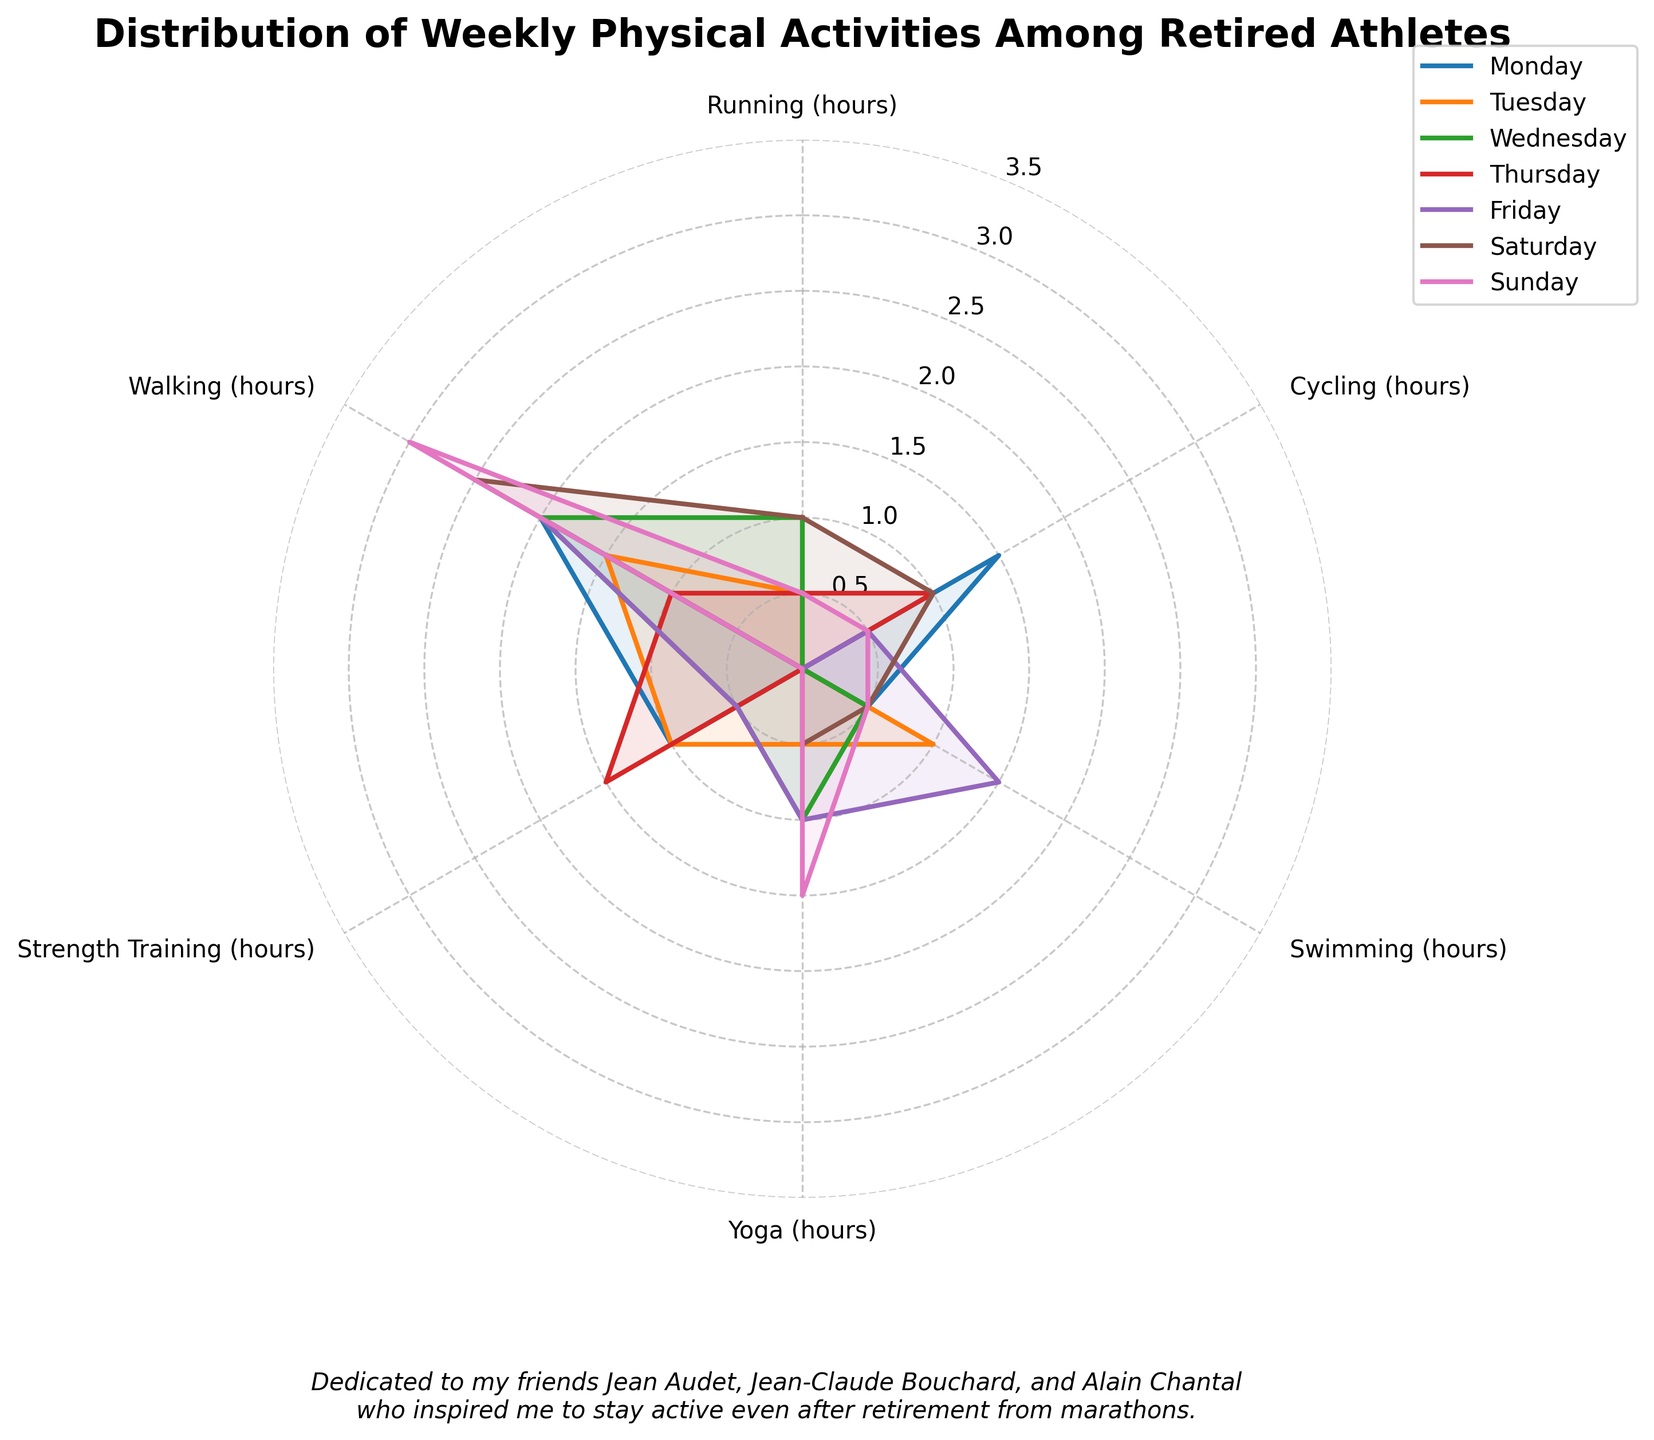What is the title of the figure? The title is displayed prominently at the top of the plot and reads "Distribution of Weekly Physical Activities Among Retired Athletes".
Answer: Distribution of Weekly Physical Activities Among Retired Athletes Which activity has the highest time on Wednesday? Look at the plot for Wednesday and identify the activity with the highest value on the associated axis.
Answer: Walking On which day did they spend the most time walking? Observe the data points for walking across all days and identify the day with the highest value. Refer to the plot area where this activity is represented.
Answer: Sunday Compare the total activity time on Monday and Sunday. Which day has more activity time? Sum the hours of all activities for both Monday and Sunday and compare the totals. Monday's total: 5 hours (1.5 + 0.5 + 1 + 2). Sunday's total: 6 hours (0.5 + 0.5 + 0.5 + 1.5 + 3).
Answer: Sunday Which two activities have exactly the same amount of time on Saturday? Check the data points for all activities on Saturday and find any two activities with identical values.
Answer: Running and Swimming How much more time is spent on Yoga on Friday compared to Tuesday? Look at the yoga data points for Friday and Tuesday and compute the difference. Yoga on Friday: 1 hour. Yoga on Tuesday: 0.5 hours. Difference: 1 - 0.5 = 0.5 hours
Answer: 0.5 hours What is the average time spent on Cycling from Monday to Thursday? Add the hours spent on Cycling from Monday to Thursday and divide by the number of days. (1.5 + 0 + 0 + 1) / 4 = 2.5 / 4 = 0.625
Answer: 0.625 hours Which day has the least variation in time spent across all activities? Check the spread of data points for each day and identify the one with the least fluctuation or range.
Answer: Thursday Is there any day where more time is spent on Strength Training than on Running? Compare the Strength Training and Running values for each day and find any day when Strength Training hours exceed Running hours.
Answer: Friday What is the sum of running hours for Tuesday, Thursday, and Sunday? Add the running hours for the specified days. Tuesday: 0.5, Thursday: 0.5, Sunday: 0.5. Total: 0.5 + 0.5 + 0.5 = 1.5 hours
Answer: 1.5 hours 